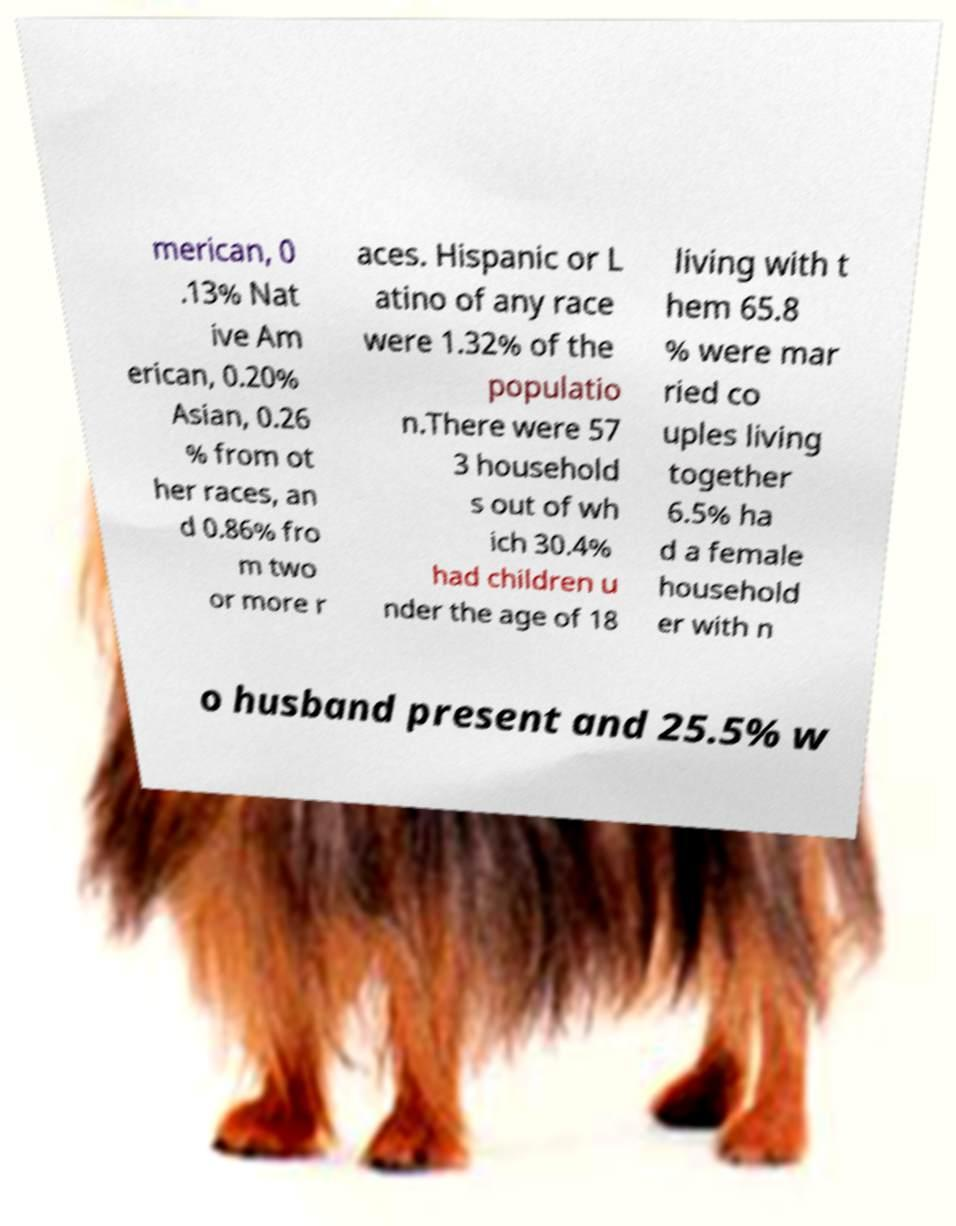For documentation purposes, I need the text within this image transcribed. Could you provide that? merican, 0 .13% Nat ive Am erican, 0.20% Asian, 0.26 % from ot her races, an d 0.86% fro m two or more r aces. Hispanic or L atino of any race were 1.32% of the populatio n.There were 57 3 household s out of wh ich 30.4% had children u nder the age of 18 living with t hem 65.8 % were mar ried co uples living together 6.5% ha d a female household er with n o husband present and 25.5% w 